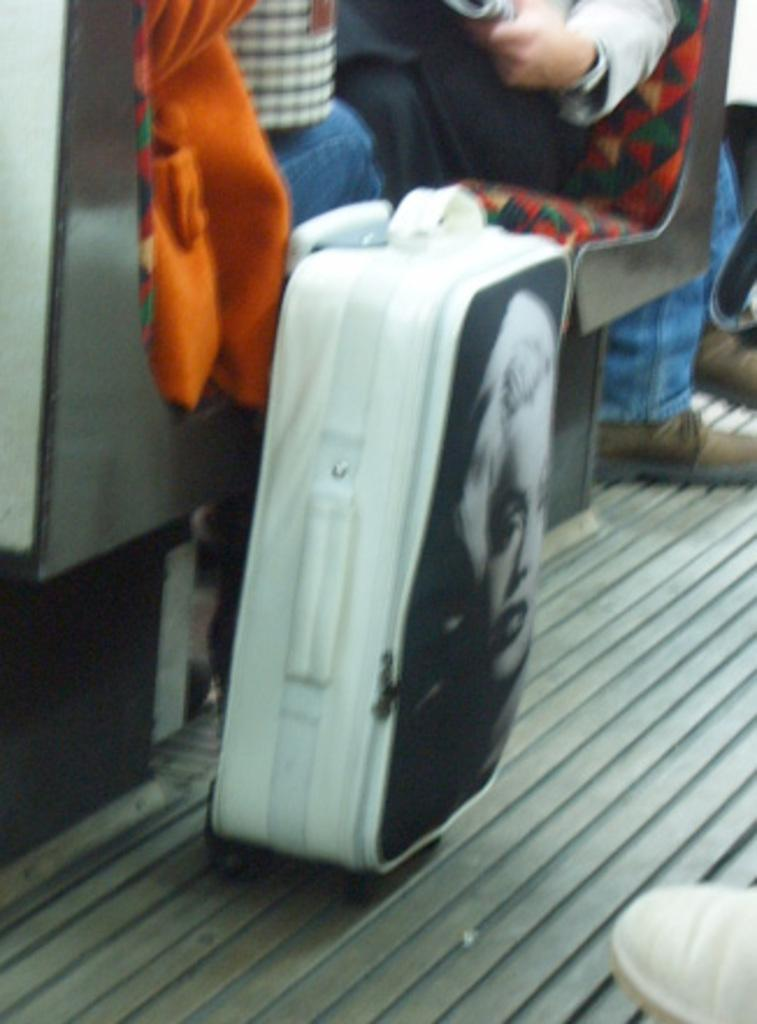What are the persons in the image doing? The persons in the image are sitting on chairs. Can you describe the chairs in the image? The chairs are occupied by the persons. What is located beside one of the persons? There is luggage beside one of the persons. What is depicted on the luggage? The luggage has a painting of a woman on it. What type of coal is being used to fuel the yak in the image? There is no yak or coal present in the image. How does the stomach of the woman depicted on the luggage feel in the image? The image does not provide information about the feelings of the woman depicted on the luggage. 